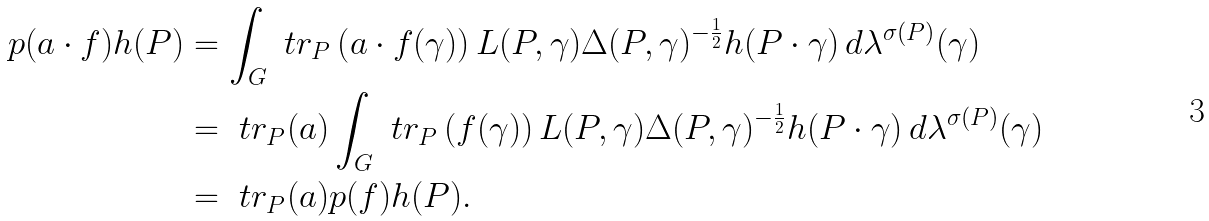Convert formula to latex. <formula><loc_0><loc_0><loc_500><loc_500>\L p ( a \cdot f ) h ( P ) & = \int _ { G } \ t r _ { P } \left ( a \cdot f ( \gamma ) \right ) L ( P , \gamma ) \Delta ( P , \gamma ) ^ { - \frac { 1 } { 2 } } h ( P \cdot \gamma ) \, d \lambda ^ { \sigma ( P ) } ( \gamma ) \\ & = \ t r _ { P } ( a ) \int _ { G } \ t r _ { P } \left ( f ( \gamma ) \right ) L ( P , \gamma ) \Delta ( P , \gamma ) ^ { - \frac { 1 } { 2 } } h ( P \cdot \gamma ) \, d \lambda ^ { \sigma ( P ) } ( \gamma ) \\ & = \ t r _ { P } ( a ) \L p ( f ) h ( P ) .</formula> 